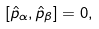<formula> <loc_0><loc_0><loc_500><loc_500>[ \hat { p } _ { \alpha } , \hat { p } _ { \beta } ] = 0 ,</formula> 